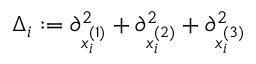Convert formula to latex. <formula><loc_0><loc_0><loc_500><loc_500>\begin{array} { r } { \Delta _ { i } \colon = \partial _ { x _ { i } ^ { ( 1 ) } } ^ { 2 } + \partial _ { x _ { i } ^ { ( 2 ) } } ^ { 2 } + \partial _ { x _ { i } ^ { ( 3 ) } } ^ { 2 } } \end{array}</formula> 